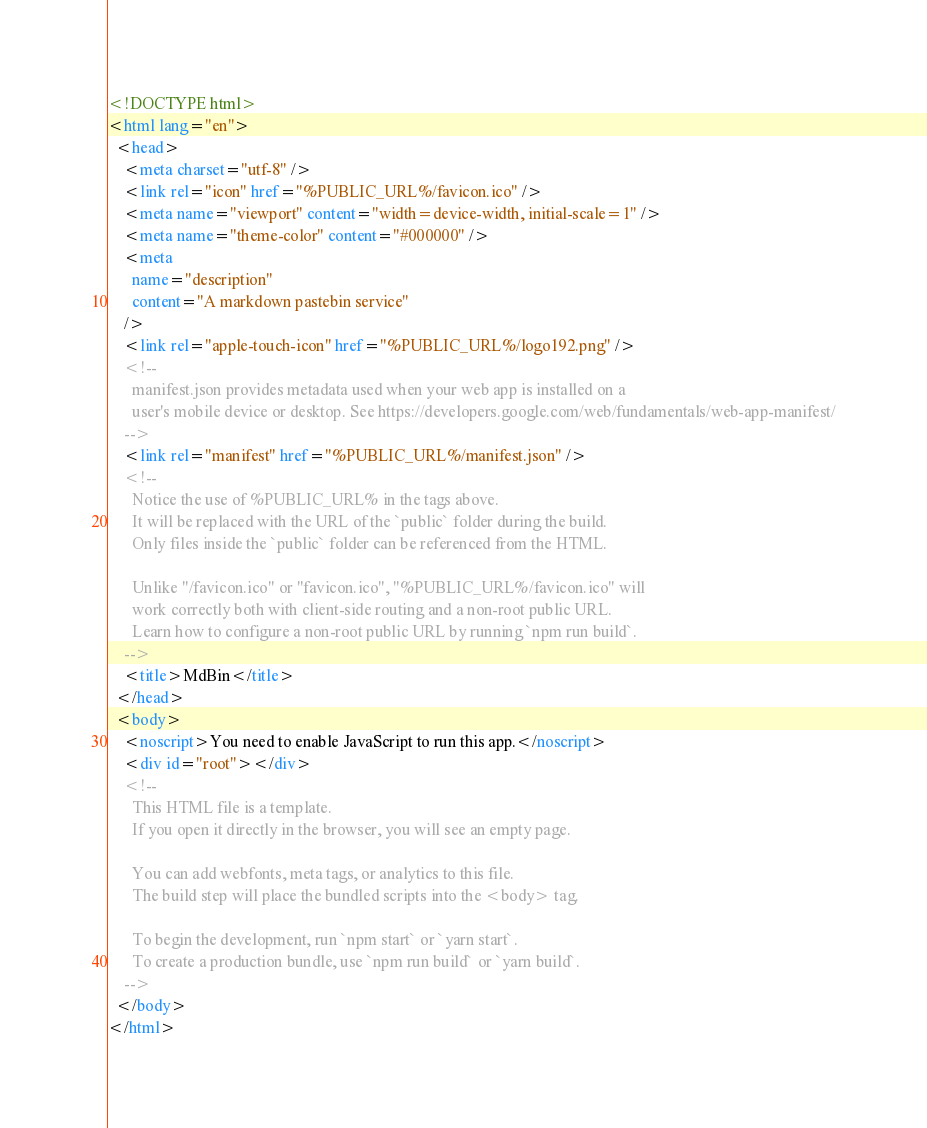<code> <loc_0><loc_0><loc_500><loc_500><_HTML_><!DOCTYPE html>
<html lang="en">
  <head>
    <meta charset="utf-8" />
    <link rel="icon" href="%PUBLIC_URL%/favicon.ico" />
    <meta name="viewport" content="width=device-width, initial-scale=1" />
    <meta name="theme-color" content="#000000" />
    <meta
      name="description"
      content="A markdown pastebin service"
    />
    <link rel="apple-touch-icon" href="%PUBLIC_URL%/logo192.png" />
    <!--
      manifest.json provides metadata used when your web app is installed on a
      user's mobile device or desktop. See https://developers.google.com/web/fundamentals/web-app-manifest/
    -->
    <link rel="manifest" href="%PUBLIC_URL%/manifest.json" />
    <!--
      Notice the use of %PUBLIC_URL% in the tags above.
      It will be replaced with the URL of the `public` folder during the build.
      Only files inside the `public` folder can be referenced from the HTML.

      Unlike "/favicon.ico" or "favicon.ico", "%PUBLIC_URL%/favicon.ico" will
      work correctly both with client-side routing and a non-root public URL.
      Learn how to configure a non-root public URL by running `npm run build`.
    -->
    <title>MdBin</title>
  </head>
  <body>
    <noscript>You need to enable JavaScript to run this app.</noscript>
    <div id="root"></div>
    <!--
      This HTML file is a template.
      If you open it directly in the browser, you will see an empty page.

      You can add webfonts, meta tags, or analytics to this file.
      The build step will place the bundled scripts into the <body> tag.

      To begin the development, run `npm start` or `yarn start`.
      To create a production bundle, use `npm run build` or `yarn build`.
    -->
  </body>
</html>
</code> 